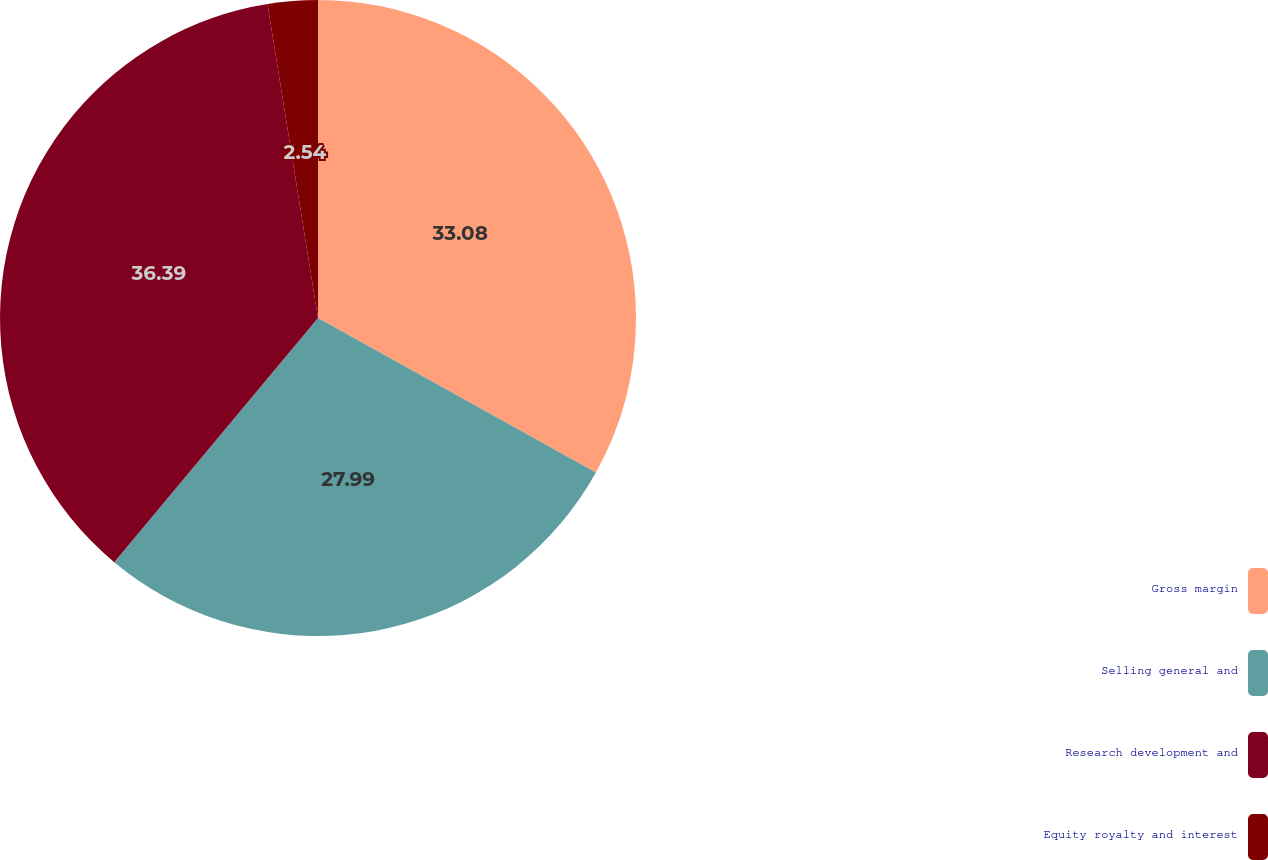<chart> <loc_0><loc_0><loc_500><loc_500><pie_chart><fcel>Gross margin<fcel>Selling general and<fcel>Research development and<fcel>Equity royalty and interest<nl><fcel>33.08%<fcel>27.99%<fcel>36.39%<fcel>2.54%<nl></chart> 